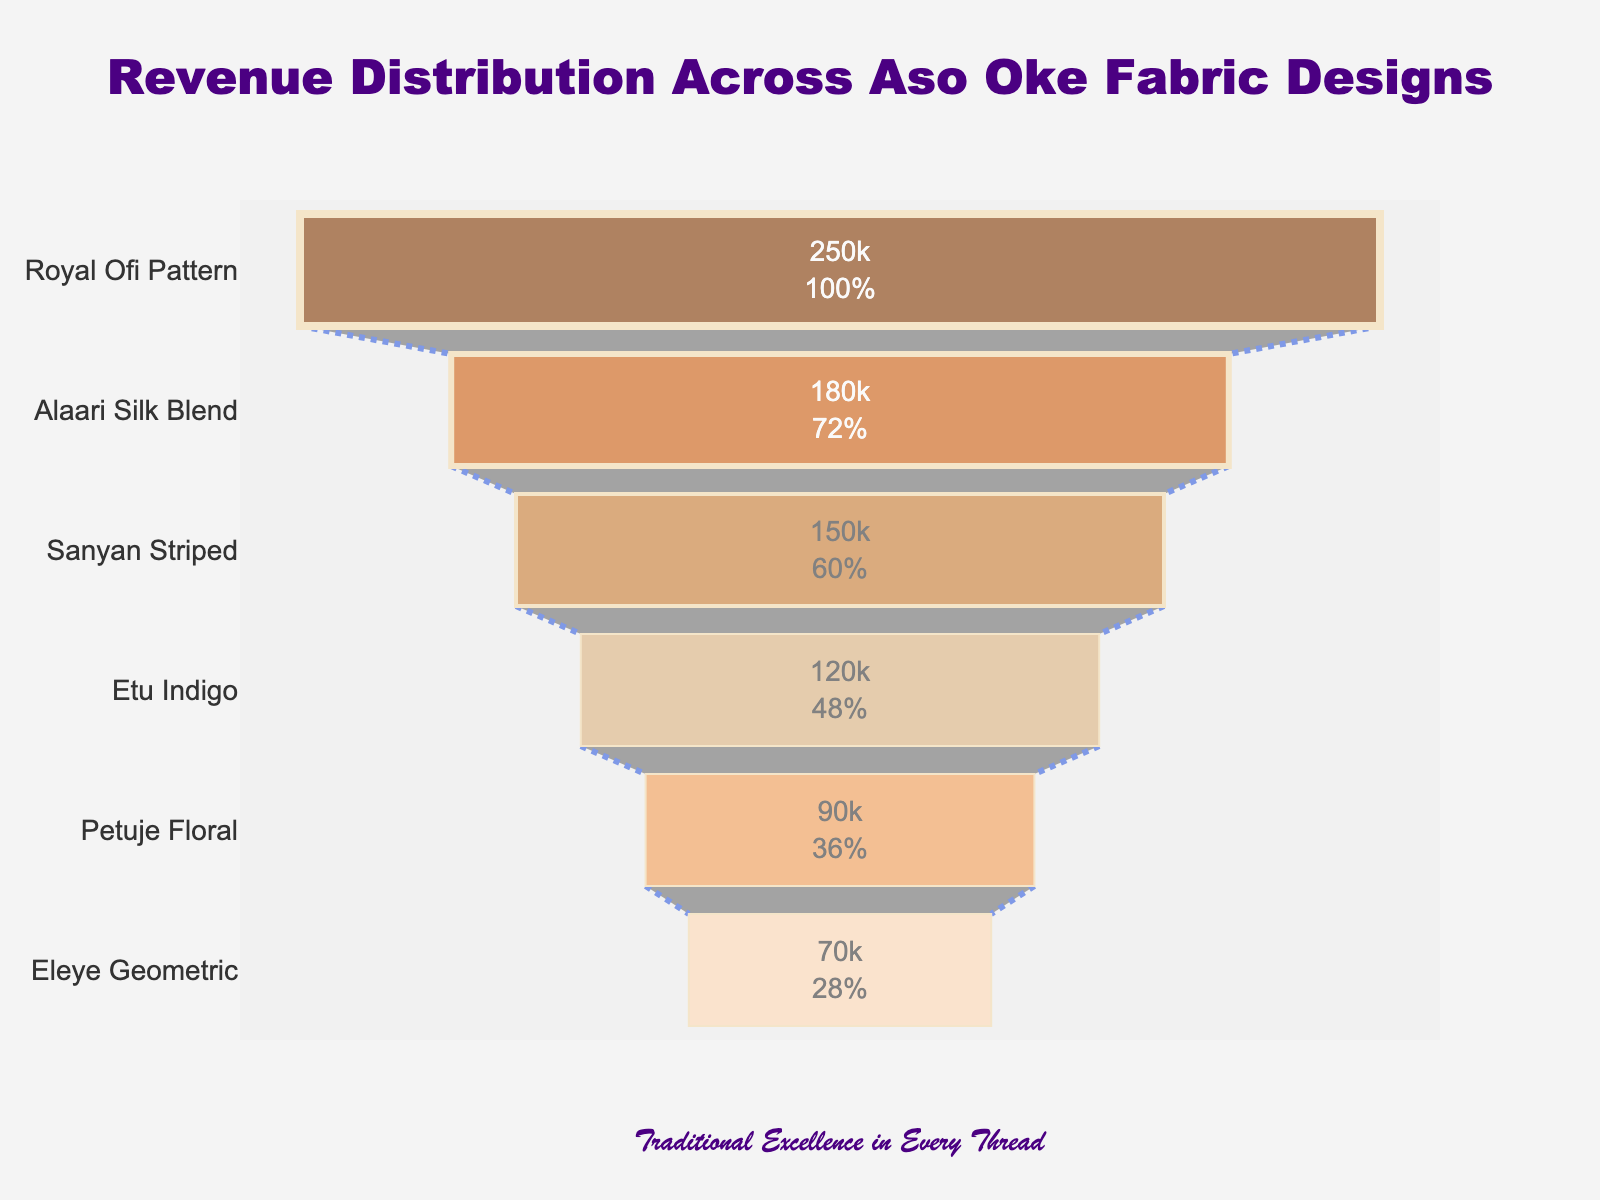What is the title of the funnel chart? The title is usually found at the top center of the chart. In this case, it reads "Revenue Distribution Across Aso Oke Fabric Designs".
Answer: Revenue Distribution Across Aso Oke Fabric Designs Which Aso Oke fabric design generated the highest revenue? The funnel chart starts with the fabric design that generated the highest revenue at the widest part. The topmost design is “Royal Ofi Pattern”.
Answer: Royal Ofi Pattern How much revenue did the "Sanyan Striped" design generate? Locate "Sanyan Striped" on the y-axis of the chart and refer to its associated value. The chart shows “Sanyan Striped” generated 150,000.
Answer: 150,000 What percentage of initial revenue does the "Etu Indigo" design represent? Find "Etu Indigo" on the y-axis and look at the percentage value inside the segment. It represents 18% of the initial revenue.
Answer: 18% Which fabric design is represented with the narrowest section in the funnel chart? The narrowest section is at the bottom of the funnel, and it is labeled "Eleye Geometric".
Answer: Eleye Geometric What is the difference in revenue between "Royal Ofi Pattern" and "Alaari Silk Blend"? Subtract the revenue of "Alaari Silk Blend" from "Royal Ofi Pattern". 250,000 - 180,000 = 70,000.
Answer: 70,000 What total revenue is generated by the top three Aso Oke fabric designs? Sum the revenues of the top three designs: Royal Ofi Pattern (250,000) + Alaari Silk Blend (180,000) + Sanyan Striped (150,000). The total is 580,000.
Answer: 580,000 How does the revenue of "Petuje Floral" compare to "Eleye Geometric"? Compare the two revenue figures: Petuje Floral (90,000) is greater than Eleye Geometric (70,000).
Answer: Petuje Floral is greater than Eleye Geometric Which Aso Oke fabric designs have revenues below 100,000? Identify all segments with revenue values less than 100,000. "Petuje Floral" (90,000) and "Eleye Geometric" (70,000).
Answer: Petuje Floral and Eleye Geometric What is the average revenue of all the Aso Oke designs displayed? Add up all the revenue values and divide by the number of designs. (250,000 + 180,000 + 150,000 + 120,000 + 90,000 + 70,000) / 6 = 860,000 / 6 = 143,333.33
Answer: 143,333.33 